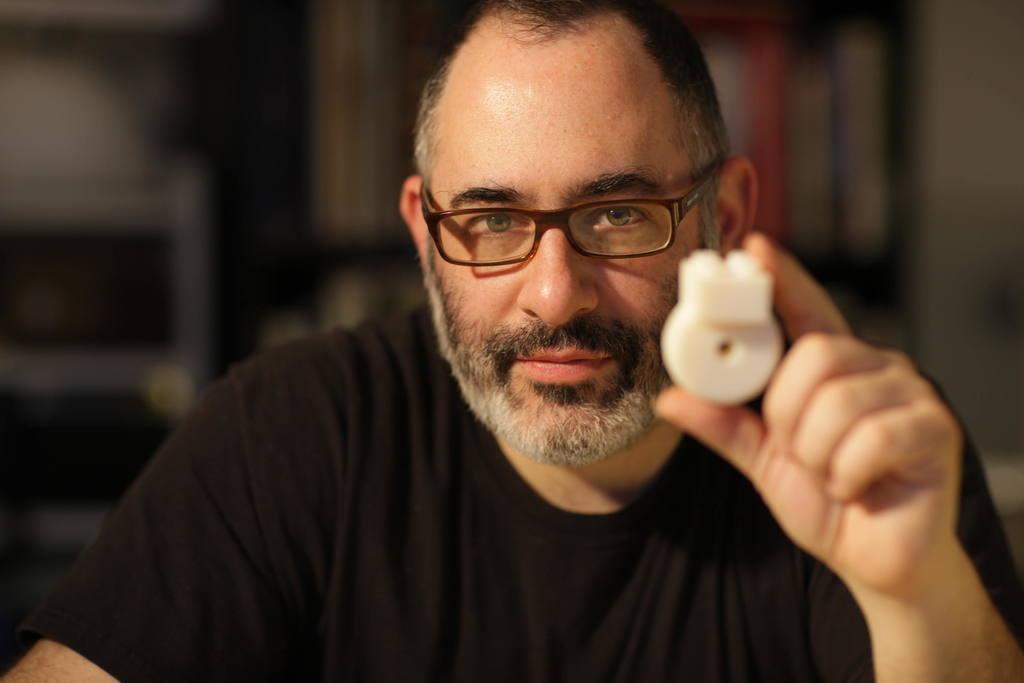In one or two sentences, can you explain what this image depicts? As we can see in the image there is a man wearing black color t shirt and the background is blurred. 